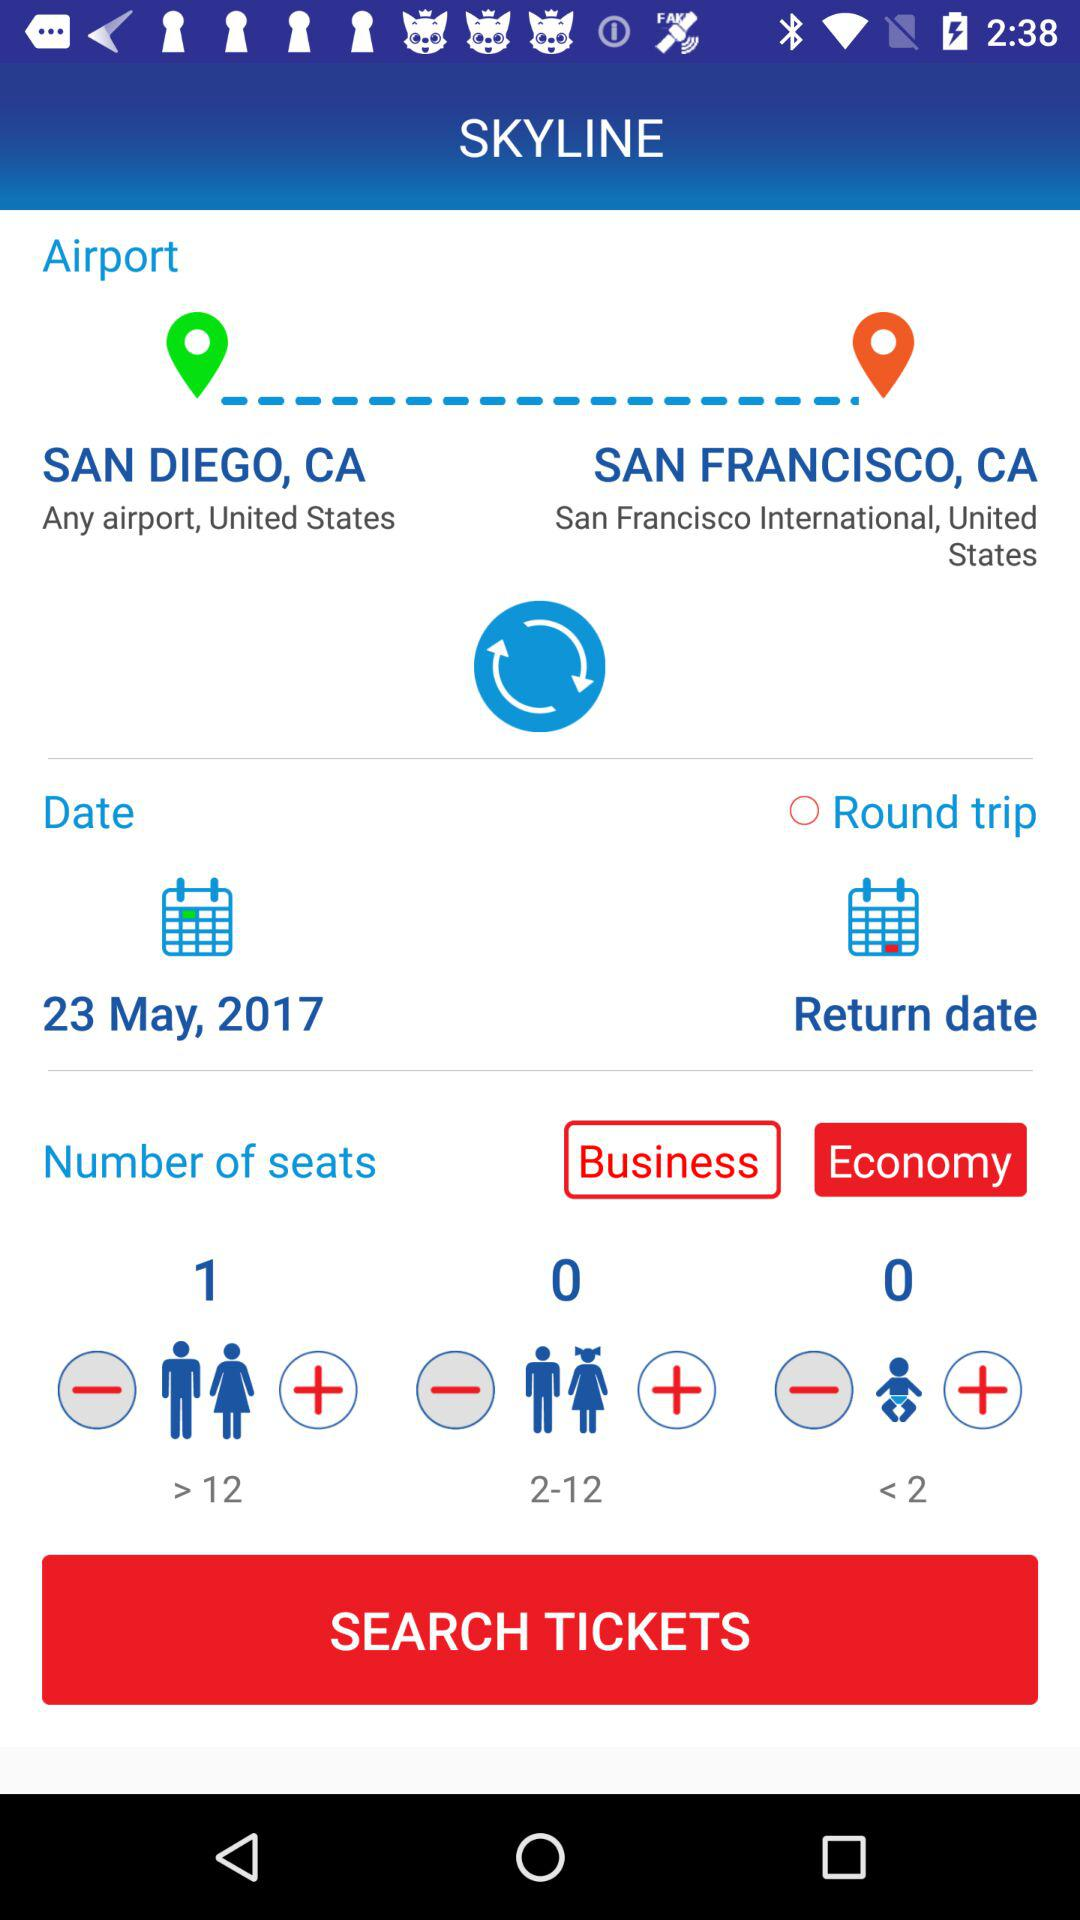Which is the arrival location? The arrival location is San Francisco, CA. 